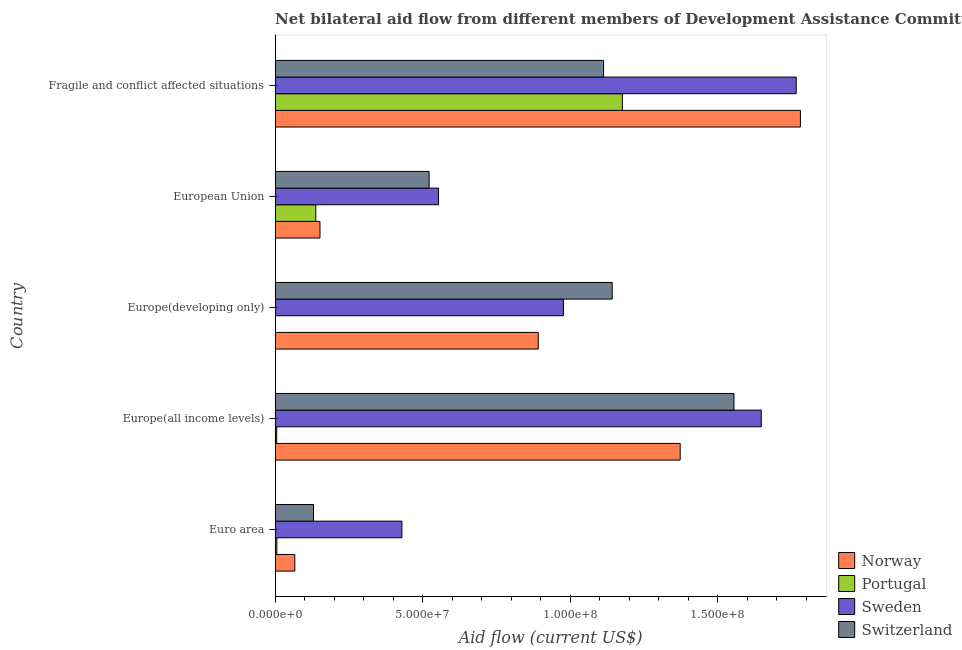How many groups of bars are there?
Provide a short and direct response. 5. Are the number of bars on each tick of the Y-axis equal?
Give a very brief answer. Yes. How many bars are there on the 5th tick from the top?
Your answer should be compact. 4. What is the label of the 1st group of bars from the top?
Keep it short and to the point. Fragile and conflict affected situations. In how many cases, is the number of bars for a given country not equal to the number of legend labels?
Provide a succinct answer. 0. What is the amount of aid given by sweden in European Union?
Your response must be concise. 5.54e+07. Across all countries, what is the maximum amount of aid given by norway?
Offer a very short reply. 1.78e+08. Across all countries, what is the minimum amount of aid given by portugal?
Provide a succinct answer. 5.00e+04. In which country was the amount of aid given by portugal maximum?
Give a very brief answer. Fragile and conflict affected situations. In which country was the amount of aid given by sweden minimum?
Your answer should be compact. Euro area. What is the total amount of aid given by portugal in the graph?
Provide a succinct answer. 1.33e+08. What is the difference between the amount of aid given by norway in Euro area and that in Europe(developing only)?
Provide a succinct answer. -8.25e+07. What is the difference between the amount of aid given by portugal in Euro area and the amount of aid given by switzerland in European Union?
Ensure brevity in your answer.  -5.16e+07. What is the average amount of aid given by switzerland per country?
Offer a very short reply. 8.92e+07. What is the difference between the amount of aid given by sweden and amount of aid given by norway in European Union?
Offer a very short reply. 4.02e+07. What is the ratio of the amount of aid given by norway in Europe(all income levels) to that in European Union?
Give a very brief answer. 9.02. Is the difference between the amount of aid given by norway in Euro area and European Union greater than the difference between the amount of aid given by portugal in Euro area and European Union?
Provide a succinct answer. Yes. What is the difference between the highest and the second highest amount of aid given by norway?
Make the answer very short. 4.07e+07. What is the difference between the highest and the lowest amount of aid given by portugal?
Your answer should be very brief. 1.18e+08. In how many countries, is the amount of aid given by switzerland greater than the average amount of aid given by switzerland taken over all countries?
Keep it short and to the point. 3. Is the sum of the amount of aid given by norway in Europe(developing only) and Fragile and conflict affected situations greater than the maximum amount of aid given by sweden across all countries?
Ensure brevity in your answer.  Yes. What does the 2nd bar from the top in European Union represents?
Provide a short and direct response. Sweden. Is it the case that in every country, the sum of the amount of aid given by norway and amount of aid given by portugal is greater than the amount of aid given by sweden?
Offer a terse response. No. How many bars are there?
Make the answer very short. 20. What is the difference between two consecutive major ticks on the X-axis?
Make the answer very short. 5.00e+07. Does the graph contain any zero values?
Ensure brevity in your answer.  No. How are the legend labels stacked?
Your answer should be compact. Vertical. What is the title of the graph?
Ensure brevity in your answer.  Net bilateral aid flow from different members of Development Assistance Committee in the year 1995. What is the label or title of the X-axis?
Your response must be concise. Aid flow (current US$). What is the label or title of the Y-axis?
Provide a short and direct response. Country. What is the Aid flow (current US$) of Norway in Euro area?
Your answer should be compact. 6.68e+06. What is the Aid flow (current US$) in Portugal in Euro area?
Offer a terse response. 6.00e+05. What is the Aid flow (current US$) of Sweden in Euro area?
Your answer should be compact. 4.30e+07. What is the Aid flow (current US$) in Switzerland in Euro area?
Your answer should be very brief. 1.30e+07. What is the Aid flow (current US$) of Norway in Europe(all income levels)?
Keep it short and to the point. 1.37e+08. What is the Aid flow (current US$) in Portugal in Europe(all income levels)?
Your answer should be compact. 5.40e+05. What is the Aid flow (current US$) of Sweden in Europe(all income levels)?
Your answer should be compact. 1.65e+08. What is the Aid flow (current US$) of Switzerland in Europe(all income levels)?
Give a very brief answer. 1.55e+08. What is the Aid flow (current US$) in Norway in Europe(developing only)?
Provide a succinct answer. 8.92e+07. What is the Aid flow (current US$) in Sweden in Europe(developing only)?
Offer a terse response. 9.77e+07. What is the Aid flow (current US$) in Switzerland in Europe(developing only)?
Make the answer very short. 1.14e+08. What is the Aid flow (current US$) of Norway in European Union?
Make the answer very short. 1.52e+07. What is the Aid flow (current US$) in Portugal in European Union?
Ensure brevity in your answer.  1.38e+07. What is the Aid flow (current US$) of Sweden in European Union?
Offer a terse response. 5.54e+07. What is the Aid flow (current US$) in Switzerland in European Union?
Your response must be concise. 5.22e+07. What is the Aid flow (current US$) of Norway in Fragile and conflict affected situations?
Offer a very short reply. 1.78e+08. What is the Aid flow (current US$) of Portugal in Fragile and conflict affected situations?
Your response must be concise. 1.18e+08. What is the Aid flow (current US$) in Sweden in Fragile and conflict affected situations?
Provide a short and direct response. 1.77e+08. What is the Aid flow (current US$) of Switzerland in Fragile and conflict affected situations?
Provide a succinct answer. 1.11e+08. Across all countries, what is the maximum Aid flow (current US$) of Norway?
Make the answer very short. 1.78e+08. Across all countries, what is the maximum Aid flow (current US$) in Portugal?
Provide a short and direct response. 1.18e+08. Across all countries, what is the maximum Aid flow (current US$) in Sweden?
Your answer should be compact. 1.77e+08. Across all countries, what is the maximum Aid flow (current US$) of Switzerland?
Make the answer very short. 1.55e+08. Across all countries, what is the minimum Aid flow (current US$) of Norway?
Your response must be concise. 6.68e+06. Across all countries, what is the minimum Aid flow (current US$) of Sweden?
Offer a very short reply. 4.30e+07. Across all countries, what is the minimum Aid flow (current US$) in Switzerland?
Your answer should be compact. 1.30e+07. What is the total Aid flow (current US$) of Norway in the graph?
Ensure brevity in your answer.  4.26e+08. What is the total Aid flow (current US$) in Portugal in the graph?
Provide a short and direct response. 1.33e+08. What is the total Aid flow (current US$) in Sweden in the graph?
Ensure brevity in your answer.  5.37e+08. What is the total Aid flow (current US$) in Switzerland in the graph?
Give a very brief answer. 4.46e+08. What is the difference between the Aid flow (current US$) in Norway in Euro area and that in Europe(all income levels)?
Make the answer very short. -1.31e+08. What is the difference between the Aid flow (current US$) in Sweden in Euro area and that in Europe(all income levels)?
Offer a very short reply. -1.22e+08. What is the difference between the Aid flow (current US$) in Switzerland in Euro area and that in Europe(all income levels)?
Your answer should be compact. -1.42e+08. What is the difference between the Aid flow (current US$) in Norway in Euro area and that in Europe(developing only)?
Keep it short and to the point. -8.25e+07. What is the difference between the Aid flow (current US$) in Portugal in Euro area and that in Europe(developing only)?
Offer a very short reply. 5.50e+05. What is the difference between the Aid flow (current US$) of Sweden in Euro area and that in Europe(developing only)?
Offer a terse response. -5.47e+07. What is the difference between the Aid flow (current US$) of Switzerland in Euro area and that in Europe(developing only)?
Ensure brevity in your answer.  -1.01e+08. What is the difference between the Aid flow (current US$) of Norway in Euro area and that in European Union?
Keep it short and to the point. -8.53e+06. What is the difference between the Aid flow (current US$) in Portugal in Euro area and that in European Union?
Your response must be concise. -1.32e+07. What is the difference between the Aid flow (current US$) in Sweden in Euro area and that in European Union?
Provide a short and direct response. -1.24e+07. What is the difference between the Aid flow (current US$) in Switzerland in Euro area and that in European Union?
Offer a very short reply. -3.92e+07. What is the difference between the Aid flow (current US$) of Norway in Euro area and that in Fragile and conflict affected situations?
Provide a succinct answer. -1.71e+08. What is the difference between the Aid flow (current US$) of Portugal in Euro area and that in Fragile and conflict affected situations?
Ensure brevity in your answer.  -1.17e+08. What is the difference between the Aid flow (current US$) in Sweden in Euro area and that in Fragile and conflict affected situations?
Your answer should be compact. -1.34e+08. What is the difference between the Aid flow (current US$) of Switzerland in Euro area and that in Fragile and conflict affected situations?
Offer a terse response. -9.83e+07. What is the difference between the Aid flow (current US$) of Norway in Europe(all income levels) and that in Europe(developing only)?
Your response must be concise. 4.81e+07. What is the difference between the Aid flow (current US$) of Portugal in Europe(all income levels) and that in Europe(developing only)?
Your response must be concise. 4.90e+05. What is the difference between the Aid flow (current US$) in Sweden in Europe(all income levels) and that in Europe(developing only)?
Make the answer very short. 6.70e+07. What is the difference between the Aid flow (current US$) of Switzerland in Europe(all income levels) and that in Europe(developing only)?
Keep it short and to the point. 4.12e+07. What is the difference between the Aid flow (current US$) of Norway in Europe(all income levels) and that in European Union?
Provide a short and direct response. 1.22e+08. What is the difference between the Aid flow (current US$) in Portugal in Europe(all income levels) and that in European Union?
Provide a succinct answer. -1.33e+07. What is the difference between the Aid flow (current US$) of Sweden in Europe(all income levels) and that in European Union?
Provide a succinct answer. 1.09e+08. What is the difference between the Aid flow (current US$) of Switzerland in Europe(all income levels) and that in European Union?
Keep it short and to the point. 1.03e+08. What is the difference between the Aid flow (current US$) in Norway in Europe(all income levels) and that in Fragile and conflict affected situations?
Your answer should be very brief. -4.07e+07. What is the difference between the Aid flow (current US$) of Portugal in Europe(all income levels) and that in Fragile and conflict affected situations?
Your answer should be very brief. -1.17e+08. What is the difference between the Aid flow (current US$) in Sweden in Europe(all income levels) and that in Fragile and conflict affected situations?
Provide a short and direct response. -1.18e+07. What is the difference between the Aid flow (current US$) in Switzerland in Europe(all income levels) and that in Fragile and conflict affected situations?
Provide a succinct answer. 4.42e+07. What is the difference between the Aid flow (current US$) in Norway in Europe(developing only) and that in European Union?
Provide a succinct answer. 7.40e+07. What is the difference between the Aid flow (current US$) of Portugal in Europe(developing only) and that in European Union?
Make the answer very short. -1.38e+07. What is the difference between the Aid flow (current US$) of Sweden in Europe(developing only) and that in European Union?
Provide a succinct answer. 4.23e+07. What is the difference between the Aid flow (current US$) of Switzerland in Europe(developing only) and that in European Union?
Make the answer very short. 6.20e+07. What is the difference between the Aid flow (current US$) in Norway in Europe(developing only) and that in Fragile and conflict affected situations?
Your response must be concise. -8.88e+07. What is the difference between the Aid flow (current US$) in Portugal in Europe(developing only) and that in Fragile and conflict affected situations?
Provide a short and direct response. -1.18e+08. What is the difference between the Aid flow (current US$) in Sweden in Europe(developing only) and that in Fragile and conflict affected situations?
Your answer should be compact. -7.88e+07. What is the difference between the Aid flow (current US$) in Switzerland in Europe(developing only) and that in Fragile and conflict affected situations?
Your answer should be compact. 2.92e+06. What is the difference between the Aid flow (current US$) of Norway in European Union and that in Fragile and conflict affected situations?
Make the answer very short. -1.63e+08. What is the difference between the Aid flow (current US$) of Portugal in European Union and that in Fragile and conflict affected situations?
Your answer should be very brief. -1.04e+08. What is the difference between the Aid flow (current US$) in Sweden in European Union and that in Fragile and conflict affected situations?
Make the answer very short. -1.21e+08. What is the difference between the Aid flow (current US$) of Switzerland in European Union and that in Fragile and conflict affected situations?
Ensure brevity in your answer.  -5.91e+07. What is the difference between the Aid flow (current US$) in Norway in Euro area and the Aid flow (current US$) in Portugal in Europe(all income levels)?
Your answer should be compact. 6.14e+06. What is the difference between the Aid flow (current US$) of Norway in Euro area and the Aid flow (current US$) of Sweden in Europe(all income levels)?
Your response must be concise. -1.58e+08. What is the difference between the Aid flow (current US$) in Norway in Euro area and the Aid flow (current US$) in Switzerland in Europe(all income levels)?
Your answer should be very brief. -1.49e+08. What is the difference between the Aid flow (current US$) in Portugal in Euro area and the Aid flow (current US$) in Sweden in Europe(all income levels)?
Offer a very short reply. -1.64e+08. What is the difference between the Aid flow (current US$) of Portugal in Euro area and the Aid flow (current US$) of Switzerland in Europe(all income levels)?
Provide a succinct answer. -1.55e+08. What is the difference between the Aid flow (current US$) of Sweden in Euro area and the Aid flow (current US$) of Switzerland in Europe(all income levels)?
Ensure brevity in your answer.  -1.12e+08. What is the difference between the Aid flow (current US$) in Norway in Euro area and the Aid flow (current US$) in Portugal in Europe(developing only)?
Provide a short and direct response. 6.63e+06. What is the difference between the Aid flow (current US$) in Norway in Euro area and the Aid flow (current US$) in Sweden in Europe(developing only)?
Provide a succinct answer. -9.10e+07. What is the difference between the Aid flow (current US$) of Norway in Euro area and the Aid flow (current US$) of Switzerland in Europe(developing only)?
Offer a terse response. -1.08e+08. What is the difference between the Aid flow (current US$) in Portugal in Euro area and the Aid flow (current US$) in Sweden in Europe(developing only)?
Offer a terse response. -9.71e+07. What is the difference between the Aid flow (current US$) of Portugal in Euro area and the Aid flow (current US$) of Switzerland in Europe(developing only)?
Your response must be concise. -1.14e+08. What is the difference between the Aid flow (current US$) of Sweden in Euro area and the Aid flow (current US$) of Switzerland in Europe(developing only)?
Your answer should be very brief. -7.12e+07. What is the difference between the Aid flow (current US$) in Norway in Euro area and the Aid flow (current US$) in Portugal in European Union?
Offer a very short reply. -7.12e+06. What is the difference between the Aid flow (current US$) in Norway in Euro area and the Aid flow (current US$) in Sweden in European Union?
Your response must be concise. -4.87e+07. What is the difference between the Aid flow (current US$) in Norway in Euro area and the Aid flow (current US$) in Switzerland in European Union?
Provide a short and direct response. -4.55e+07. What is the difference between the Aid flow (current US$) in Portugal in Euro area and the Aid flow (current US$) in Sweden in European Union?
Your response must be concise. -5.48e+07. What is the difference between the Aid flow (current US$) in Portugal in Euro area and the Aid flow (current US$) in Switzerland in European Union?
Your answer should be compact. -5.16e+07. What is the difference between the Aid flow (current US$) in Sweden in Euro area and the Aid flow (current US$) in Switzerland in European Union?
Offer a terse response. -9.22e+06. What is the difference between the Aid flow (current US$) in Norway in Euro area and the Aid flow (current US$) in Portugal in Fragile and conflict affected situations?
Your answer should be very brief. -1.11e+08. What is the difference between the Aid flow (current US$) of Norway in Euro area and the Aid flow (current US$) of Sweden in Fragile and conflict affected situations?
Your response must be concise. -1.70e+08. What is the difference between the Aid flow (current US$) in Norway in Euro area and the Aid flow (current US$) in Switzerland in Fragile and conflict affected situations?
Provide a short and direct response. -1.05e+08. What is the difference between the Aid flow (current US$) of Portugal in Euro area and the Aid flow (current US$) of Sweden in Fragile and conflict affected situations?
Keep it short and to the point. -1.76e+08. What is the difference between the Aid flow (current US$) in Portugal in Euro area and the Aid flow (current US$) in Switzerland in Fragile and conflict affected situations?
Offer a very short reply. -1.11e+08. What is the difference between the Aid flow (current US$) in Sweden in Euro area and the Aid flow (current US$) in Switzerland in Fragile and conflict affected situations?
Provide a short and direct response. -6.83e+07. What is the difference between the Aid flow (current US$) in Norway in Europe(all income levels) and the Aid flow (current US$) in Portugal in Europe(developing only)?
Keep it short and to the point. 1.37e+08. What is the difference between the Aid flow (current US$) in Norway in Europe(all income levels) and the Aid flow (current US$) in Sweden in Europe(developing only)?
Provide a short and direct response. 3.95e+07. What is the difference between the Aid flow (current US$) of Norway in Europe(all income levels) and the Aid flow (current US$) of Switzerland in Europe(developing only)?
Offer a terse response. 2.30e+07. What is the difference between the Aid flow (current US$) in Portugal in Europe(all income levels) and the Aid flow (current US$) in Sweden in Europe(developing only)?
Give a very brief answer. -9.72e+07. What is the difference between the Aid flow (current US$) in Portugal in Europe(all income levels) and the Aid flow (current US$) in Switzerland in Europe(developing only)?
Give a very brief answer. -1.14e+08. What is the difference between the Aid flow (current US$) in Sweden in Europe(all income levels) and the Aid flow (current US$) in Switzerland in Europe(developing only)?
Provide a short and direct response. 5.05e+07. What is the difference between the Aid flow (current US$) in Norway in Europe(all income levels) and the Aid flow (current US$) in Portugal in European Union?
Offer a very short reply. 1.23e+08. What is the difference between the Aid flow (current US$) of Norway in Europe(all income levels) and the Aid flow (current US$) of Sweden in European Union?
Your answer should be compact. 8.19e+07. What is the difference between the Aid flow (current US$) in Norway in Europe(all income levels) and the Aid flow (current US$) in Switzerland in European Union?
Keep it short and to the point. 8.50e+07. What is the difference between the Aid flow (current US$) in Portugal in Europe(all income levels) and the Aid flow (current US$) in Sweden in European Union?
Keep it short and to the point. -5.48e+07. What is the difference between the Aid flow (current US$) in Portugal in Europe(all income levels) and the Aid flow (current US$) in Switzerland in European Union?
Your answer should be very brief. -5.16e+07. What is the difference between the Aid flow (current US$) in Sweden in Europe(all income levels) and the Aid flow (current US$) in Switzerland in European Union?
Give a very brief answer. 1.13e+08. What is the difference between the Aid flow (current US$) in Norway in Europe(all income levels) and the Aid flow (current US$) in Portugal in Fragile and conflict affected situations?
Give a very brief answer. 1.96e+07. What is the difference between the Aid flow (current US$) in Norway in Europe(all income levels) and the Aid flow (current US$) in Sweden in Fragile and conflict affected situations?
Your response must be concise. -3.93e+07. What is the difference between the Aid flow (current US$) of Norway in Europe(all income levels) and the Aid flow (current US$) of Switzerland in Fragile and conflict affected situations?
Offer a very short reply. 2.60e+07. What is the difference between the Aid flow (current US$) of Portugal in Europe(all income levels) and the Aid flow (current US$) of Sweden in Fragile and conflict affected situations?
Provide a short and direct response. -1.76e+08. What is the difference between the Aid flow (current US$) of Portugal in Europe(all income levels) and the Aid flow (current US$) of Switzerland in Fragile and conflict affected situations?
Your answer should be compact. -1.11e+08. What is the difference between the Aid flow (current US$) of Sweden in Europe(all income levels) and the Aid flow (current US$) of Switzerland in Fragile and conflict affected situations?
Your response must be concise. 5.34e+07. What is the difference between the Aid flow (current US$) of Norway in Europe(developing only) and the Aid flow (current US$) of Portugal in European Union?
Give a very brief answer. 7.54e+07. What is the difference between the Aid flow (current US$) of Norway in Europe(developing only) and the Aid flow (current US$) of Sweden in European Union?
Give a very brief answer. 3.38e+07. What is the difference between the Aid flow (current US$) in Norway in Europe(developing only) and the Aid flow (current US$) in Switzerland in European Union?
Offer a very short reply. 3.70e+07. What is the difference between the Aid flow (current US$) of Portugal in Europe(developing only) and the Aid flow (current US$) of Sweden in European Union?
Your answer should be very brief. -5.53e+07. What is the difference between the Aid flow (current US$) in Portugal in Europe(developing only) and the Aid flow (current US$) in Switzerland in European Union?
Provide a succinct answer. -5.21e+07. What is the difference between the Aid flow (current US$) in Sweden in Europe(developing only) and the Aid flow (current US$) in Switzerland in European Union?
Provide a succinct answer. 4.55e+07. What is the difference between the Aid flow (current US$) in Norway in Europe(developing only) and the Aid flow (current US$) in Portugal in Fragile and conflict affected situations?
Provide a succinct answer. -2.85e+07. What is the difference between the Aid flow (current US$) in Norway in Europe(developing only) and the Aid flow (current US$) in Sweden in Fragile and conflict affected situations?
Offer a terse response. -8.74e+07. What is the difference between the Aid flow (current US$) of Norway in Europe(developing only) and the Aid flow (current US$) of Switzerland in Fragile and conflict affected situations?
Give a very brief answer. -2.21e+07. What is the difference between the Aid flow (current US$) in Portugal in Europe(developing only) and the Aid flow (current US$) in Sweden in Fragile and conflict affected situations?
Your answer should be compact. -1.76e+08. What is the difference between the Aid flow (current US$) of Portugal in Europe(developing only) and the Aid flow (current US$) of Switzerland in Fragile and conflict affected situations?
Your answer should be compact. -1.11e+08. What is the difference between the Aid flow (current US$) in Sweden in Europe(developing only) and the Aid flow (current US$) in Switzerland in Fragile and conflict affected situations?
Your response must be concise. -1.36e+07. What is the difference between the Aid flow (current US$) in Norway in European Union and the Aid flow (current US$) in Portugal in Fragile and conflict affected situations?
Give a very brief answer. -1.02e+08. What is the difference between the Aid flow (current US$) of Norway in European Union and the Aid flow (current US$) of Sweden in Fragile and conflict affected situations?
Offer a very short reply. -1.61e+08. What is the difference between the Aid flow (current US$) of Norway in European Union and the Aid flow (current US$) of Switzerland in Fragile and conflict affected situations?
Keep it short and to the point. -9.61e+07. What is the difference between the Aid flow (current US$) in Portugal in European Union and the Aid flow (current US$) in Sweden in Fragile and conflict affected situations?
Make the answer very short. -1.63e+08. What is the difference between the Aid flow (current US$) of Portugal in European Union and the Aid flow (current US$) of Switzerland in Fragile and conflict affected situations?
Offer a terse response. -9.75e+07. What is the difference between the Aid flow (current US$) in Sweden in European Union and the Aid flow (current US$) in Switzerland in Fragile and conflict affected situations?
Your answer should be compact. -5.59e+07. What is the average Aid flow (current US$) of Norway per country?
Ensure brevity in your answer.  8.53e+07. What is the average Aid flow (current US$) of Portugal per country?
Your response must be concise. 2.65e+07. What is the average Aid flow (current US$) in Sweden per country?
Give a very brief answer. 1.07e+08. What is the average Aid flow (current US$) of Switzerland per country?
Offer a very short reply. 8.92e+07. What is the difference between the Aid flow (current US$) of Norway and Aid flow (current US$) of Portugal in Euro area?
Your answer should be very brief. 6.08e+06. What is the difference between the Aid flow (current US$) in Norway and Aid flow (current US$) in Sweden in Euro area?
Make the answer very short. -3.63e+07. What is the difference between the Aid flow (current US$) in Norway and Aid flow (current US$) in Switzerland in Euro area?
Offer a terse response. -6.34e+06. What is the difference between the Aid flow (current US$) in Portugal and Aid flow (current US$) in Sweden in Euro area?
Give a very brief answer. -4.24e+07. What is the difference between the Aid flow (current US$) of Portugal and Aid flow (current US$) of Switzerland in Euro area?
Your answer should be compact. -1.24e+07. What is the difference between the Aid flow (current US$) of Sweden and Aid flow (current US$) of Switzerland in Euro area?
Your response must be concise. 3.00e+07. What is the difference between the Aid flow (current US$) of Norway and Aid flow (current US$) of Portugal in Europe(all income levels)?
Offer a very short reply. 1.37e+08. What is the difference between the Aid flow (current US$) of Norway and Aid flow (current US$) of Sweden in Europe(all income levels)?
Make the answer very short. -2.75e+07. What is the difference between the Aid flow (current US$) of Norway and Aid flow (current US$) of Switzerland in Europe(all income levels)?
Give a very brief answer. -1.82e+07. What is the difference between the Aid flow (current US$) of Portugal and Aid flow (current US$) of Sweden in Europe(all income levels)?
Provide a short and direct response. -1.64e+08. What is the difference between the Aid flow (current US$) in Portugal and Aid flow (current US$) in Switzerland in Europe(all income levels)?
Offer a terse response. -1.55e+08. What is the difference between the Aid flow (current US$) of Sweden and Aid flow (current US$) of Switzerland in Europe(all income levels)?
Provide a succinct answer. 9.24e+06. What is the difference between the Aid flow (current US$) in Norway and Aid flow (current US$) in Portugal in Europe(developing only)?
Offer a terse response. 8.91e+07. What is the difference between the Aid flow (current US$) in Norway and Aid flow (current US$) in Sweden in Europe(developing only)?
Your response must be concise. -8.54e+06. What is the difference between the Aid flow (current US$) in Norway and Aid flow (current US$) in Switzerland in Europe(developing only)?
Make the answer very short. -2.50e+07. What is the difference between the Aid flow (current US$) in Portugal and Aid flow (current US$) in Sweden in Europe(developing only)?
Offer a terse response. -9.76e+07. What is the difference between the Aid flow (current US$) in Portugal and Aid flow (current US$) in Switzerland in Europe(developing only)?
Give a very brief answer. -1.14e+08. What is the difference between the Aid flow (current US$) of Sweden and Aid flow (current US$) of Switzerland in Europe(developing only)?
Your answer should be compact. -1.65e+07. What is the difference between the Aid flow (current US$) of Norway and Aid flow (current US$) of Portugal in European Union?
Provide a short and direct response. 1.41e+06. What is the difference between the Aid flow (current US$) in Norway and Aid flow (current US$) in Sweden in European Union?
Your answer should be compact. -4.02e+07. What is the difference between the Aid flow (current US$) of Norway and Aid flow (current US$) of Switzerland in European Union?
Your answer should be compact. -3.70e+07. What is the difference between the Aid flow (current US$) in Portugal and Aid flow (current US$) in Sweden in European Union?
Keep it short and to the point. -4.16e+07. What is the difference between the Aid flow (current US$) of Portugal and Aid flow (current US$) of Switzerland in European Union?
Offer a terse response. -3.84e+07. What is the difference between the Aid flow (current US$) of Sweden and Aid flow (current US$) of Switzerland in European Union?
Make the answer very short. 3.18e+06. What is the difference between the Aid flow (current US$) in Norway and Aid flow (current US$) in Portugal in Fragile and conflict affected situations?
Your answer should be compact. 6.03e+07. What is the difference between the Aid flow (current US$) of Norway and Aid flow (current US$) of Sweden in Fragile and conflict affected situations?
Your response must be concise. 1.43e+06. What is the difference between the Aid flow (current US$) in Norway and Aid flow (current US$) in Switzerland in Fragile and conflict affected situations?
Offer a terse response. 6.67e+07. What is the difference between the Aid flow (current US$) in Portugal and Aid flow (current US$) in Sweden in Fragile and conflict affected situations?
Provide a short and direct response. -5.89e+07. What is the difference between the Aid flow (current US$) in Portugal and Aid flow (current US$) in Switzerland in Fragile and conflict affected situations?
Ensure brevity in your answer.  6.36e+06. What is the difference between the Aid flow (current US$) in Sweden and Aid flow (current US$) in Switzerland in Fragile and conflict affected situations?
Your answer should be very brief. 6.52e+07. What is the ratio of the Aid flow (current US$) of Norway in Euro area to that in Europe(all income levels)?
Your response must be concise. 0.05. What is the ratio of the Aid flow (current US$) in Sweden in Euro area to that in Europe(all income levels)?
Keep it short and to the point. 0.26. What is the ratio of the Aid flow (current US$) in Switzerland in Euro area to that in Europe(all income levels)?
Give a very brief answer. 0.08. What is the ratio of the Aid flow (current US$) of Norway in Euro area to that in Europe(developing only)?
Provide a succinct answer. 0.07. What is the ratio of the Aid flow (current US$) in Portugal in Euro area to that in Europe(developing only)?
Keep it short and to the point. 12. What is the ratio of the Aid flow (current US$) in Sweden in Euro area to that in Europe(developing only)?
Give a very brief answer. 0.44. What is the ratio of the Aid flow (current US$) in Switzerland in Euro area to that in Europe(developing only)?
Keep it short and to the point. 0.11. What is the ratio of the Aid flow (current US$) in Norway in Euro area to that in European Union?
Make the answer very short. 0.44. What is the ratio of the Aid flow (current US$) of Portugal in Euro area to that in European Union?
Ensure brevity in your answer.  0.04. What is the ratio of the Aid flow (current US$) of Sweden in Euro area to that in European Union?
Make the answer very short. 0.78. What is the ratio of the Aid flow (current US$) in Switzerland in Euro area to that in European Union?
Offer a terse response. 0.25. What is the ratio of the Aid flow (current US$) of Norway in Euro area to that in Fragile and conflict affected situations?
Give a very brief answer. 0.04. What is the ratio of the Aid flow (current US$) of Portugal in Euro area to that in Fragile and conflict affected situations?
Offer a terse response. 0.01. What is the ratio of the Aid flow (current US$) in Sweden in Euro area to that in Fragile and conflict affected situations?
Provide a succinct answer. 0.24. What is the ratio of the Aid flow (current US$) of Switzerland in Euro area to that in Fragile and conflict affected situations?
Your response must be concise. 0.12. What is the ratio of the Aid flow (current US$) in Norway in Europe(all income levels) to that in Europe(developing only)?
Offer a terse response. 1.54. What is the ratio of the Aid flow (current US$) of Sweden in Europe(all income levels) to that in Europe(developing only)?
Provide a short and direct response. 1.69. What is the ratio of the Aid flow (current US$) in Switzerland in Europe(all income levels) to that in Europe(developing only)?
Your answer should be very brief. 1.36. What is the ratio of the Aid flow (current US$) of Norway in Europe(all income levels) to that in European Union?
Offer a very short reply. 9.02. What is the ratio of the Aid flow (current US$) of Portugal in Europe(all income levels) to that in European Union?
Offer a terse response. 0.04. What is the ratio of the Aid flow (current US$) of Sweden in Europe(all income levels) to that in European Union?
Make the answer very short. 2.97. What is the ratio of the Aid flow (current US$) in Switzerland in Europe(all income levels) to that in European Union?
Ensure brevity in your answer.  2.98. What is the ratio of the Aid flow (current US$) of Norway in Europe(all income levels) to that in Fragile and conflict affected situations?
Give a very brief answer. 0.77. What is the ratio of the Aid flow (current US$) in Portugal in Europe(all income levels) to that in Fragile and conflict affected situations?
Provide a succinct answer. 0. What is the ratio of the Aid flow (current US$) in Sweden in Europe(all income levels) to that in Fragile and conflict affected situations?
Your response must be concise. 0.93. What is the ratio of the Aid flow (current US$) of Switzerland in Europe(all income levels) to that in Fragile and conflict affected situations?
Your answer should be very brief. 1.4. What is the ratio of the Aid flow (current US$) of Norway in Europe(developing only) to that in European Union?
Your answer should be very brief. 5.86. What is the ratio of the Aid flow (current US$) of Portugal in Europe(developing only) to that in European Union?
Give a very brief answer. 0. What is the ratio of the Aid flow (current US$) in Sweden in Europe(developing only) to that in European Union?
Make the answer very short. 1.76. What is the ratio of the Aid flow (current US$) of Switzerland in Europe(developing only) to that in European Union?
Your response must be concise. 2.19. What is the ratio of the Aid flow (current US$) of Norway in Europe(developing only) to that in Fragile and conflict affected situations?
Make the answer very short. 0.5. What is the ratio of the Aid flow (current US$) of Sweden in Europe(developing only) to that in Fragile and conflict affected situations?
Provide a succinct answer. 0.55. What is the ratio of the Aid flow (current US$) of Switzerland in Europe(developing only) to that in Fragile and conflict affected situations?
Offer a terse response. 1.03. What is the ratio of the Aid flow (current US$) of Norway in European Union to that in Fragile and conflict affected situations?
Ensure brevity in your answer.  0.09. What is the ratio of the Aid flow (current US$) of Portugal in European Union to that in Fragile and conflict affected situations?
Provide a short and direct response. 0.12. What is the ratio of the Aid flow (current US$) of Sweden in European Union to that in Fragile and conflict affected situations?
Your answer should be compact. 0.31. What is the ratio of the Aid flow (current US$) in Switzerland in European Union to that in Fragile and conflict affected situations?
Provide a short and direct response. 0.47. What is the difference between the highest and the second highest Aid flow (current US$) of Norway?
Make the answer very short. 4.07e+07. What is the difference between the highest and the second highest Aid flow (current US$) of Portugal?
Provide a succinct answer. 1.04e+08. What is the difference between the highest and the second highest Aid flow (current US$) in Sweden?
Provide a succinct answer. 1.18e+07. What is the difference between the highest and the second highest Aid flow (current US$) of Switzerland?
Ensure brevity in your answer.  4.12e+07. What is the difference between the highest and the lowest Aid flow (current US$) in Norway?
Keep it short and to the point. 1.71e+08. What is the difference between the highest and the lowest Aid flow (current US$) in Portugal?
Offer a terse response. 1.18e+08. What is the difference between the highest and the lowest Aid flow (current US$) in Sweden?
Keep it short and to the point. 1.34e+08. What is the difference between the highest and the lowest Aid flow (current US$) in Switzerland?
Your answer should be very brief. 1.42e+08. 